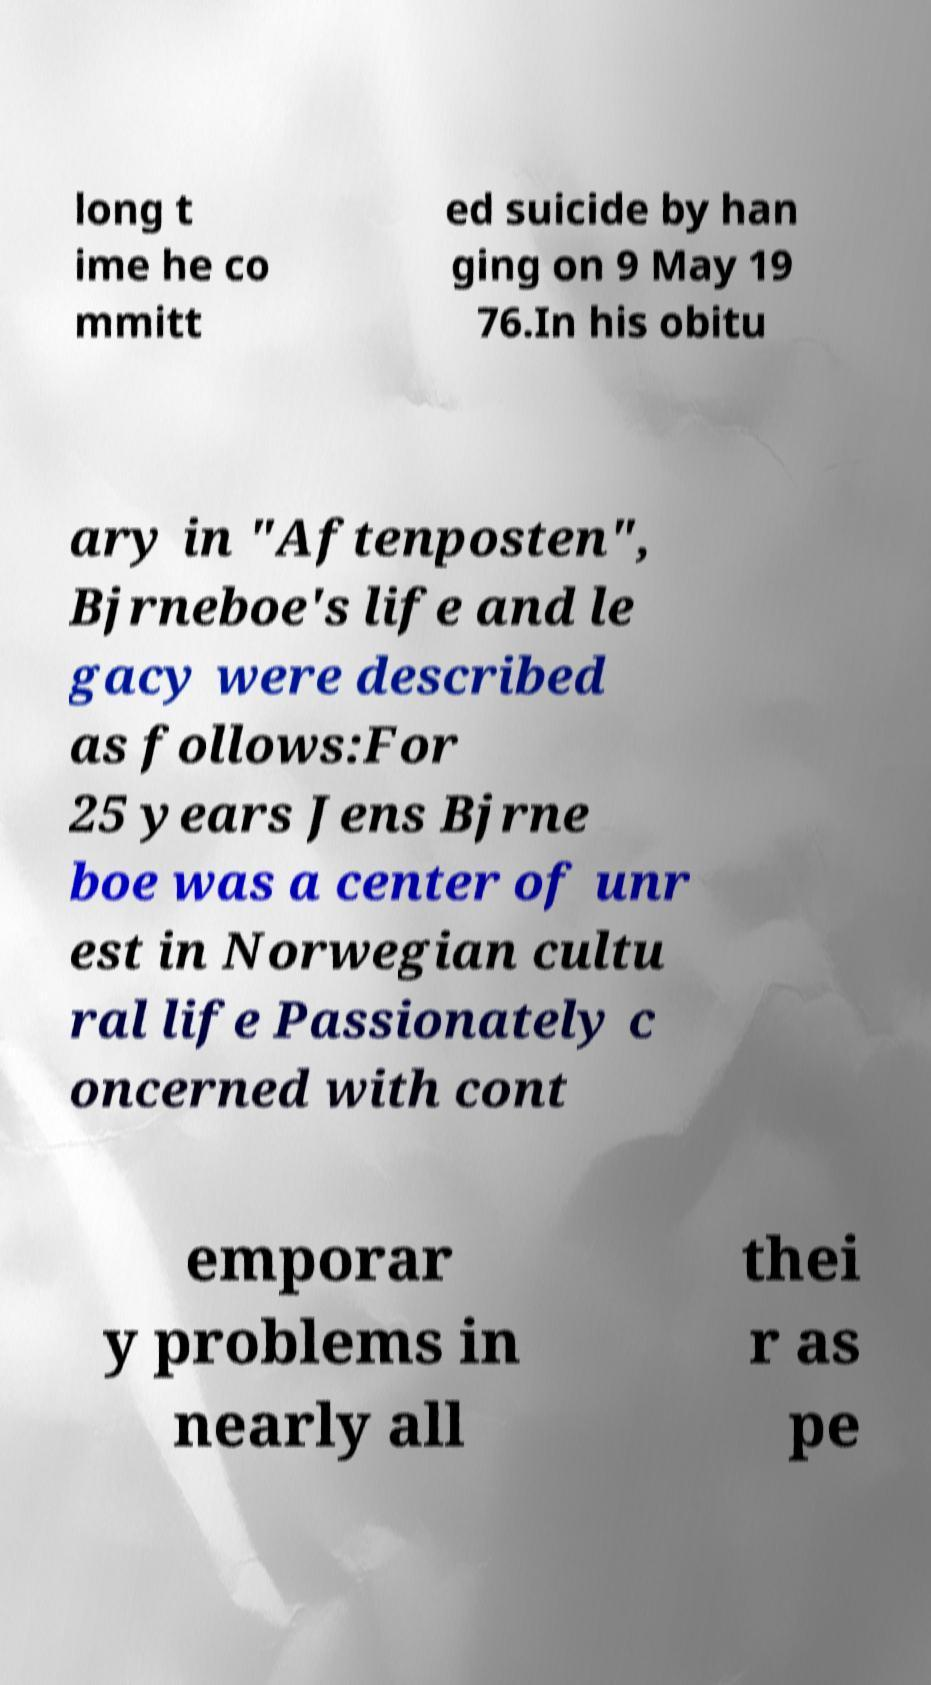Can you accurately transcribe the text from the provided image for me? long t ime he co mmitt ed suicide by han ging on 9 May 19 76.In his obitu ary in "Aftenposten", Bjrneboe's life and le gacy were described as follows:For 25 years Jens Bjrne boe was a center of unr est in Norwegian cultu ral life Passionately c oncerned with cont emporar y problems in nearly all thei r as pe 